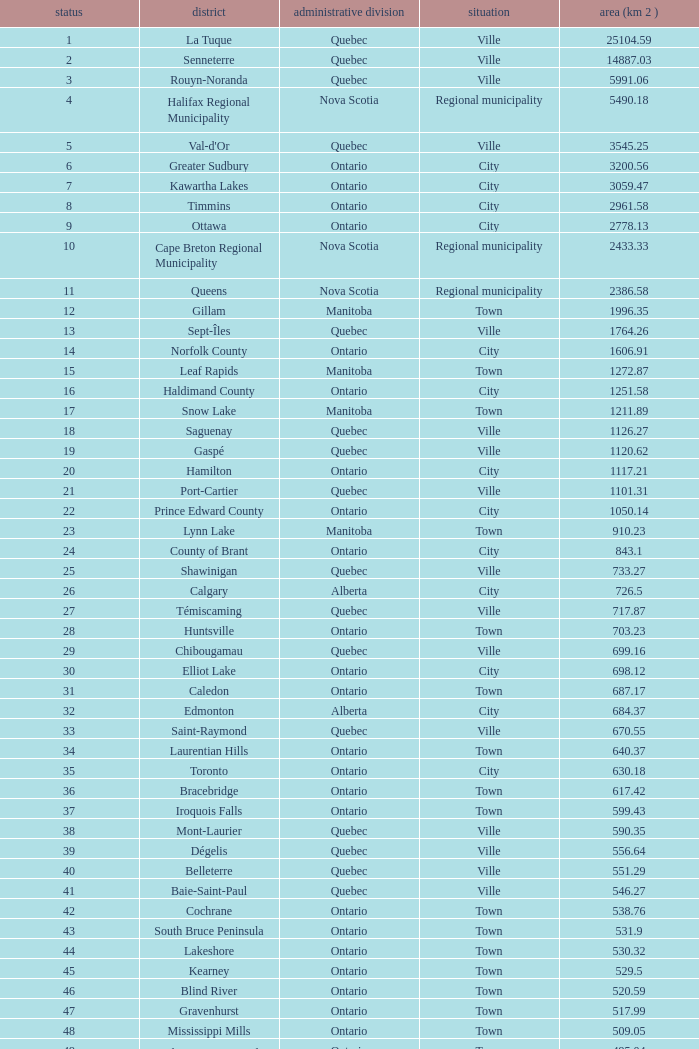What is the highest Area (KM 2) for the Province of Ontario, that has the Status of Town, a Municipality of Minto, and a Rank that's smaller than 84? None. 